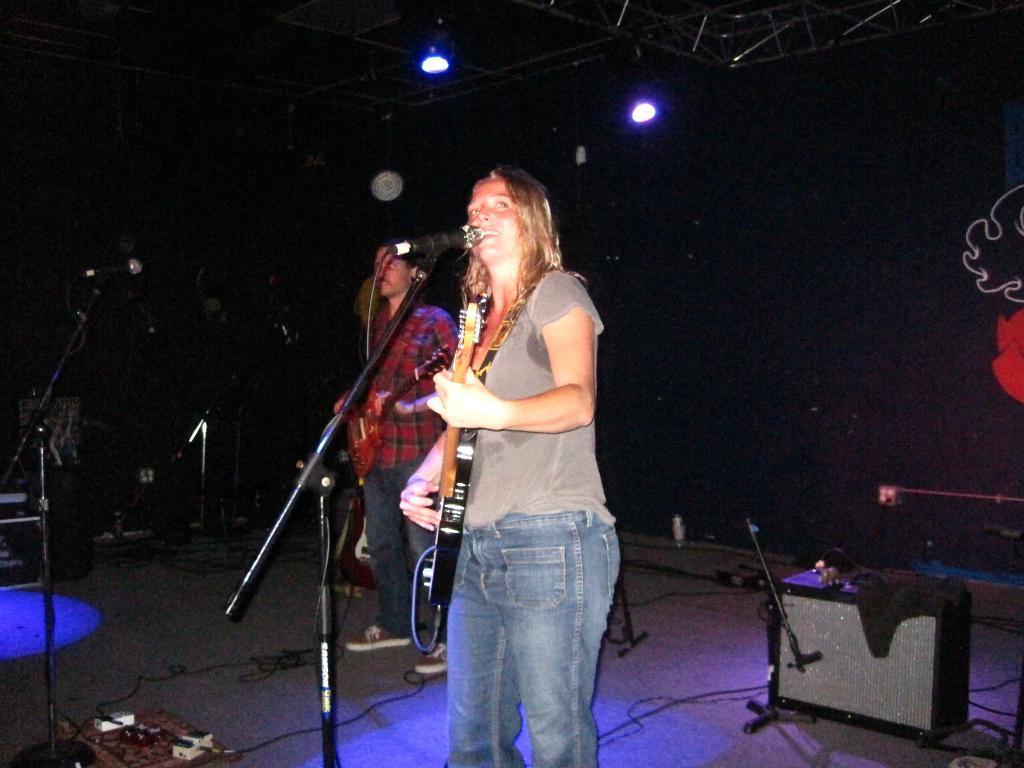Please provide a concise description of this image. This is a live performance of a band. In the center of the picture woman standing and playing guitar. In front of her there is a microphone. On the left there is a microphone. In the foreground there is a box, plug box and cables. In the background there is black curtain. On the top there are iron frames and focus lights. 